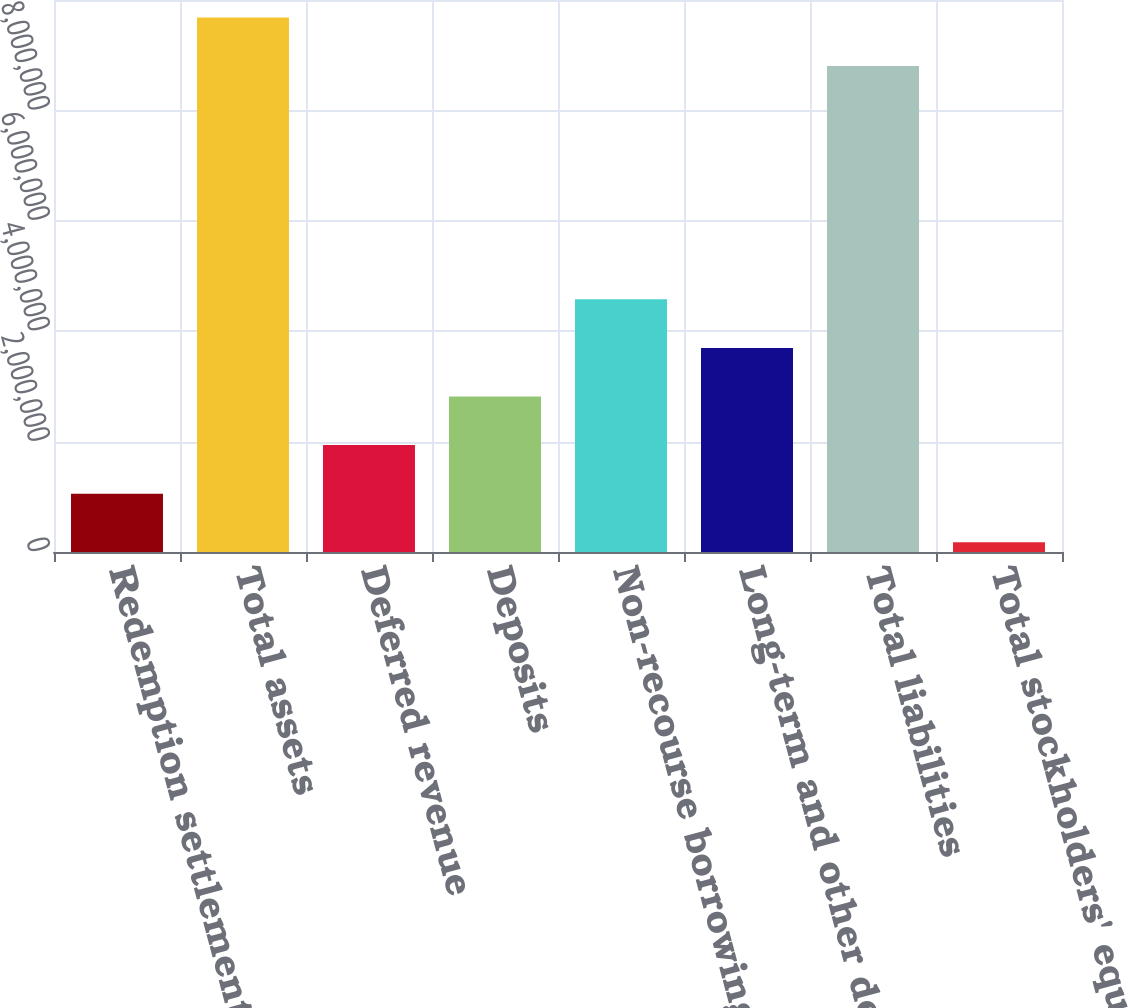Convert chart to OTSL. <chart><loc_0><loc_0><loc_500><loc_500><bar_chart><fcel>Redemption settlement assets<fcel>Total assets<fcel>Deferred revenue<fcel>Deposits<fcel>Non-recourse borrowings of<fcel>Long-term and other debt<fcel>Total liabilities<fcel>Total stockholders' equity<nl><fcel>1.05639e+06<fcel>9.68471e+06<fcel>1.93682e+06<fcel>2.81725e+06<fcel>4.57811e+06<fcel>3.69768e+06<fcel>8.80428e+06<fcel>175966<nl></chart> 